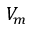Convert formula to latex. <formula><loc_0><loc_0><loc_500><loc_500>V _ { m }</formula> 